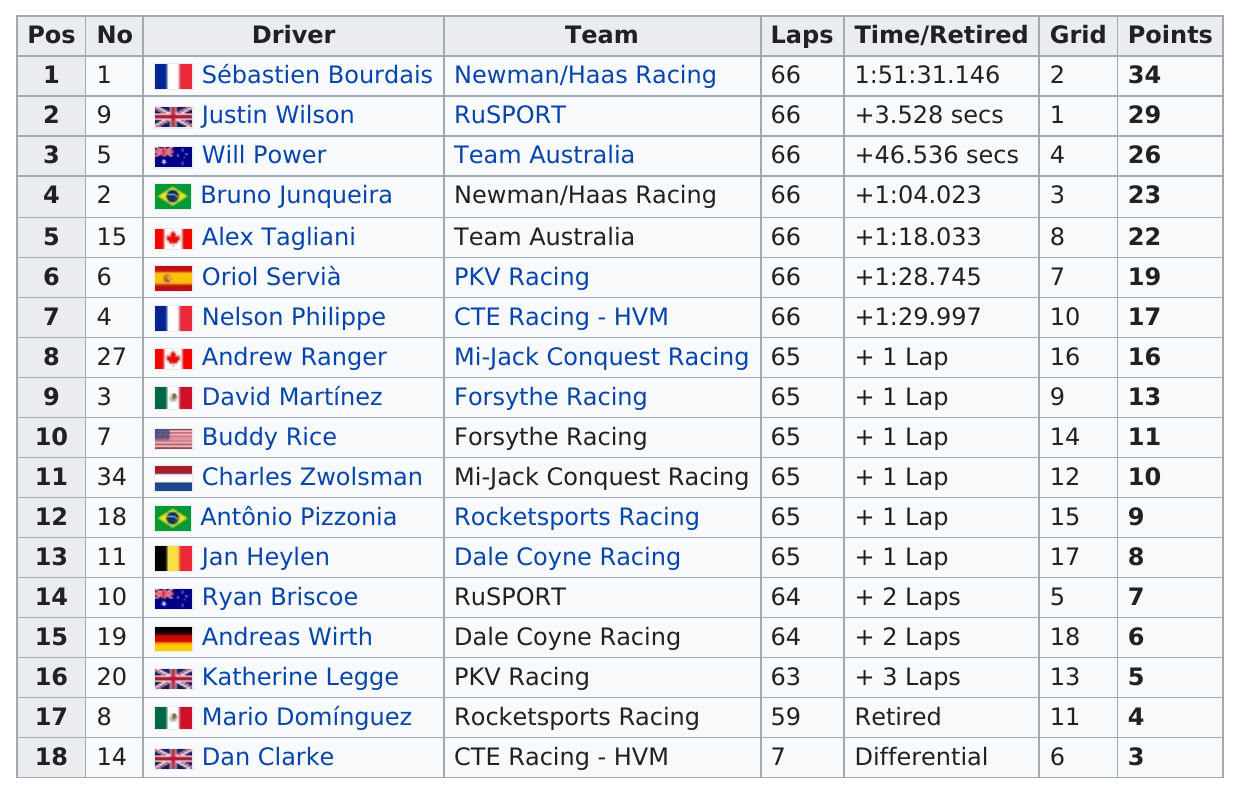Give some essential details in this illustration. Out of the drivers who did not complete more than 60 laps, two did not complete more than 60 laps. The person identified as the only racer from Mi-Jack Conquest Racing is Charles Zwolsman. Antônio Pizzonia is a driver from Brazil, and Bruno Junqueira is also from Brazil Of the drivers in this group, 3 of them are from England. Dan Clark completed 7 laps. 